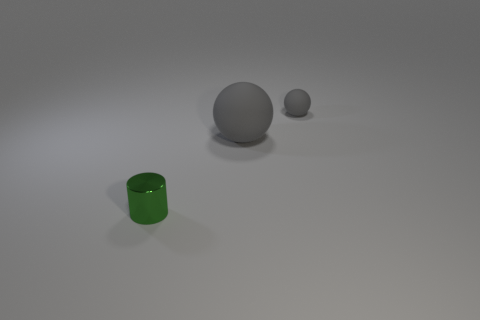Add 2 large cyan rubber things. How many objects exist? 5 Subtract all balls. How many objects are left? 1 Subtract 0 purple spheres. How many objects are left? 3 Subtract all gray spheres. Subtract all large things. How many objects are left? 0 Add 3 small green metal objects. How many small green metal objects are left? 4 Add 2 large gray balls. How many large gray balls exist? 3 